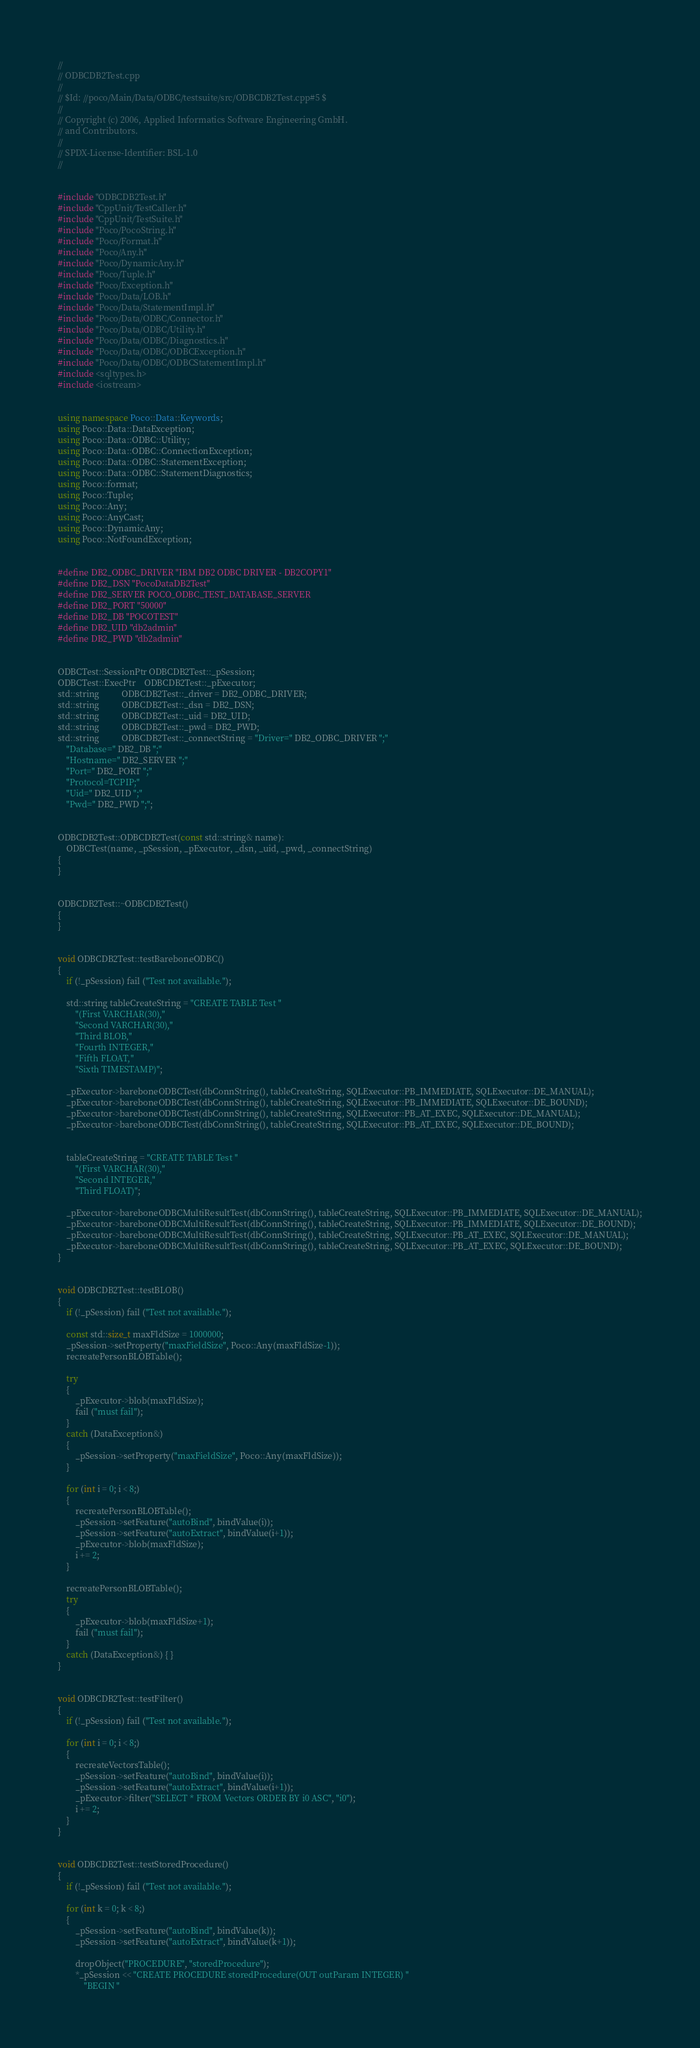Convert code to text. <code><loc_0><loc_0><loc_500><loc_500><_C++_>//
// ODBCDB2Test.cpp
//
// $Id: //poco/Main/Data/ODBC/testsuite/src/ODBCDB2Test.cpp#5 $
//
// Copyright (c) 2006, Applied Informatics Software Engineering GmbH.
// and Contributors.
//
// SPDX-License-Identifier:	BSL-1.0
//


#include "ODBCDB2Test.h"
#include "CppUnit/TestCaller.h"
#include "CppUnit/TestSuite.h"
#include "Poco/PocoString.h"
#include "Poco/Format.h"
#include "Poco/Any.h"
#include "Poco/DynamicAny.h"
#include "Poco/Tuple.h"
#include "Poco/Exception.h"
#include "Poco/Data/LOB.h"
#include "Poco/Data/StatementImpl.h"
#include "Poco/Data/ODBC/Connector.h"
#include "Poco/Data/ODBC/Utility.h"
#include "Poco/Data/ODBC/Diagnostics.h"
#include "Poco/Data/ODBC/ODBCException.h"
#include "Poco/Data/ODBC/ODBCStatementImpl.h"
#include <sqltypes.h>
#include <iostream>


using namespace Poco::Data::Keywords;
using Poco::Data::DataException;
using Poco::Data::ODBC::Utility;
using Poco::Data::ODBC::ConnectionException;
using Poco::Data::ODBC::StatementException;
using Poco::Data::ODBC::StatementDiagnostics;
using Poco::format;
using Poco::Tuple;
using Poco::Any;
using Poco::AnyCast;
using Poco::DynamicAny;
using Poco::NotFoundException;


#define DB2_ODBC_DRIVER "IBM DB2 ODBC DRIVER - DB2COPY1"
#define DB2_DSN "PocoDataDB2Test"
#define DB2_SERVER POCO_ODBC_TEST_DATABASE_SERVER
#define DB2_PORT "50000"
#define DB2_DB "POCOTEST"
#define DB2_UID "db2admin"
#define DB2_PWD "db2admin"


ODBCTest::SessionPtr ODBCDB2Test::_pSession;
ODBCTest::ExecPtr    ODBCDB2Test::_pExecutor;
std::string          ODBCDB2Test::_driver = DB2_ODBC_DRIVER;
std::string          ODBCDB2Test::_dsn = DB2_DSN;
std::string          ODBCDB2Test::_uid = DB2_UID;
std::string          ODBCDB2Test::_pwd = DB2_PWD;
std::string          ODBCDB2Test::_connectString = "Driver=" DB2_ODBC_DRIVER ";"
	"Database=" DB2_DB ";"
	"Hostname=" DB2_SERVER ";"
	"Port=" DB2_PORT ";"
	"Protocol=TCPIP;"
	"Uid=" DB2_UID ";"
	"Pwd=" DB2_PWD ";";


ODBCDB2Test::ODBCDB2Test(const std::string& name): 
	ODBCTest(name, _pSession, _pExecutor, _dsn, _uid, _pwd, _connectString)
{
}


ODBCDB2Test::~ODBCDB2Test()
{
}


void ODBCDB2Test::testBareboneODBC()
{
	if (!_pSession) fail ("Test not available.");

	std::string tableCreateString = "CREATE TABLE Test "
		"(First VARCHAR(30),"
		"Second VARCHAR(30),"
		"Third BLOB,"
		"Fourth INTEGER,"
		"Fifth FLOAT,"
		"Sixth TIMESTAMP)";

	_pExecutor->bareboneODBCTest(dbConnString(), tableCreateString, SQLExecutor::PB_IMMEDIATE, SQLExecutor::DE_MANUAL);
	_pExecutor->bareboneODBCTest(dbConnString(), tableCreateString, SQLExecutor::PB_IMMEDIATE, SQLExecutor::DE_BOUND);
	_pExecutor->bareboneODBCTest(dbConnString(), tableCreateString, SQLExecutor::PB_AT_EXEC, SQLExecutor::DE_MANUAL);
	_pExecutor->bareboneODBCTest(dbConnString(), tableCreateString, SQLExecutor::PB_AT_EXEC, SQLExecutor::DE_BOUND);


	tableCreateString = "CREATE TABLE Test "
		"(First VARCHAR(30),"
		"Second INTEGER,"
		"Third FLOAT)";

	_pExecutor->bareboneODBCMultiResultTest(dbConnString(), tableCreateString, SQLExecutor::PB_IMMEDIATE, SQLExecutor::DE_MANUAL);
	_pExecutor->bareboneODBCMultiResultTest(dbConnString(), tableCreateString, SQLExecutor::PB_IMMEDIATE, SQLExecutor::DE_BOUND);
	_pExecutor->bareboneODBCMultiResultTest(dbConnString(), tableCreateString, SQLExecutor::PB_AT_EXEC, SQLExecutor::DE_MANUAL);
	_pExecutor->bareboneODBCMultiResultTest(dbConnString(), tableCreateString, SQLExecutor::PB_AT_EXEC, SQLExecutor::DE_BOUND);
}


void ODBCDB2Test::testBLOB()
{
	if (!_pSession) fail ("Test not available.");
	
	const std::size_t maxFldSize = 1000000;
	_pSession->setProperty("maxFieldSize", Poco::Any(maxFldSize-1));
	recreatePersonBLOBTable();

	try
	{
		_pExecutor->blob(maxFldSize);
		fail ("must fail");
	}
	catch (DataException&) 
	{
		_pSession->setProperty("maxFieldSize", Poco::Any(maxFldSize));
	}

	for (int i = 0; i < 8;)
	{
		recreatePersonBLOBTable();
		_pSession->setFeature("autoBind", bindValue(i));
		_pSession->setFeature("autoExtract", bindValue(i+1));
		_pExecutor->blob(maxFldSize);
		i += 2;
	}

	recreatePersonBLOBTable();
	try
	{
		_pExecutor->blob(maxFldSize+1);
		fail ("must fail");
	}
	catch (DataException&) { }
}


void ODBCDB2Test::testFilter()
{
	if (!_pSession) fail ("Test not available.");

	for (int i = 0; i < 8;)
	{
		recreateVectorsTable();
		_pSession->setFeature("autoBind", bindValue(i));
		_pSession->setFeature("autoExtract", bindValue(i+1));
		_pExecutor->filter("SELECT * FROM Vectors ORDER BY i0 ASC", "i0");
		i += 2;
	}
}


void ODBCDB2Test::testStoredProcedure()
{
	if (!_pSession) fail ("Test not available.");

	for (int k = 0; k < 8;)
	{
		_pSession->setFeature("autoBind", bindValue(k));
		_pSession->setFeature("autoExtract", bindValue(k+1));

		dropObject("PROCEDURE", "storedProcedure");
		*_pSession << "CREATE PROCEDURE storedProcedure(OUT outParam INTEGER) "
			"BEGIN "</code> 